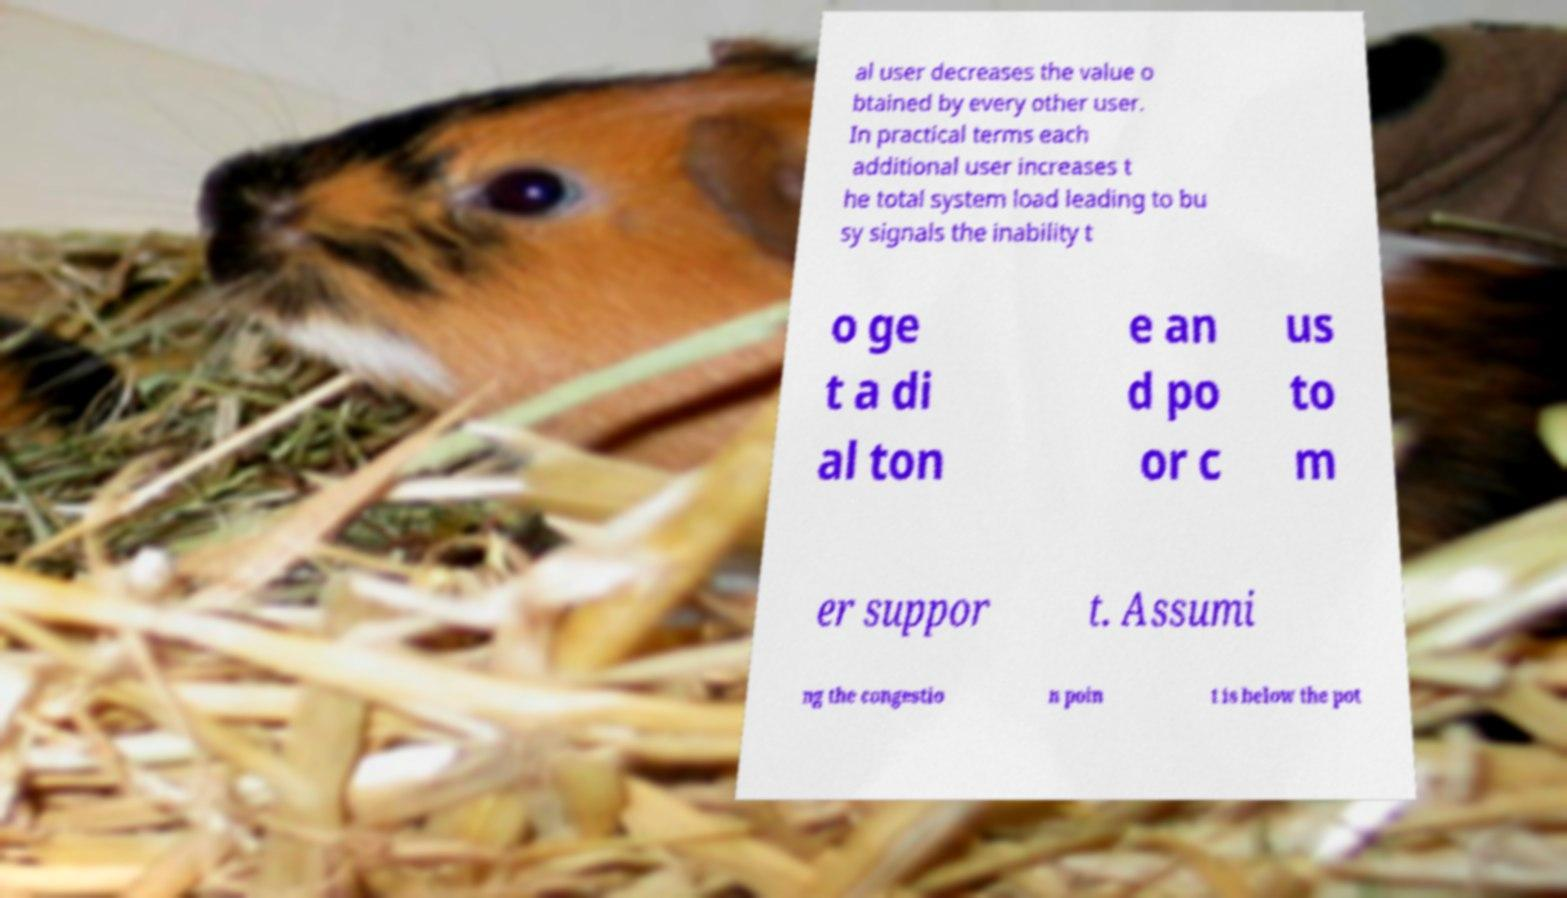Please read and relay the text visible in this image. What does it say? al user decreases the value o btained by every other user. In practical terms each additional user increases t he total system load leading to bu sy signals the inability t o ge t a di al ton e an d po or c us to m er suppor t. Assumi ng the congestio n poin t is below the pot 